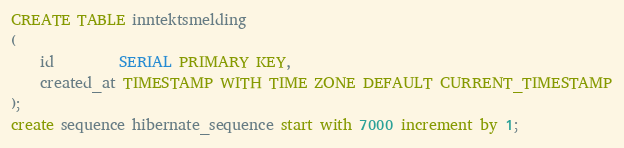Convert code to text. <code><loc_0><loc_0><loc_500><loc_500><_SQL_>CREATE TABLE inntektsmelding
(
    id         SERIAL PRIMARY KEY,
    created_at TIMESTAMP WITH TIME ZONE DEFAULT CURRENT_TIMESTAMP
);
create sequence hibernate_sequence start with 7000 increment by 1;</code> 